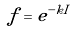<formula> <loc_0><loc_0><loc_500><loc_500>f = e ^ { - k I }</formula> 